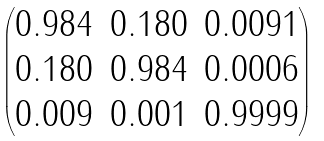Convert formula to latex. <formula><loc_0><loc_0><loc_500><loc_500>\begin{pmatrix} 0 . 9 8 4 & 0 . 1 8 0 & 0 . 0 0 9 1 \\ 0 . 1 8 0 & 0 . 9 8 4 & 0 . 0 0 0 6 \\ 0 . 0 0 9 & 0 . 0 0 1 & 0 . 9 9 9 9 \end{pmatrix}</formula> 